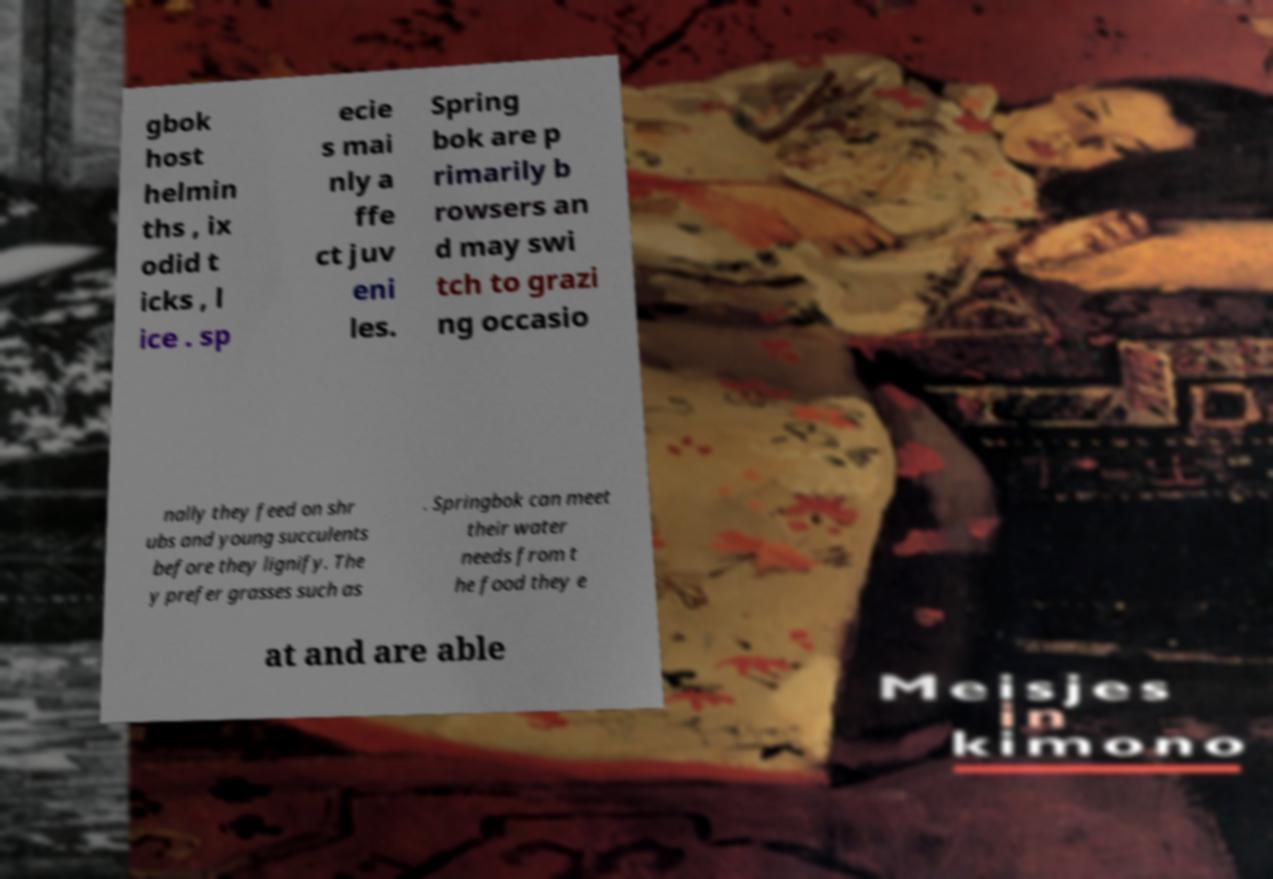Please read and relay the text visible in this image. What does it say? gbok host helmin ths , ix odid t icks , l ice . sp ecie s mai nly a ffe ct juv eni les. Spring bok are p rimarily b rowsers an d may swi tch to grazi ng occasio nally they feed on shr ubs and young succulents before they lignify. The y prefer grasses such as . Springbok can meet their water needs from t he food they e at and are able 